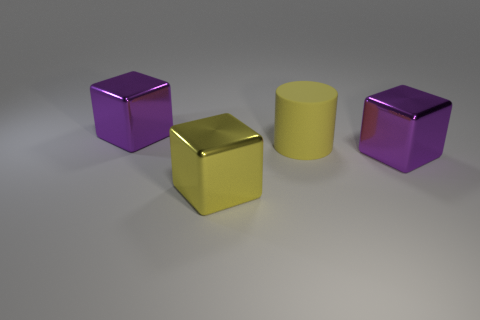How many other big things have the same color as the large rubber thing?
Your answer should be very brief. 1. Are there more tiny red rubber blocks than large cylinders?
Offer a very short reply. No. There is a metallic object that is both in front of the large matte thing and left of the rubber object; what is its size?
Make the answer very short. Large. Is the large purple thing that is behind the big yellow rubber cylinder made of the same material as the big purple object that is in front of the big yellow matte cylinder?
Ensure brevity in your answer.  Yes. What shape is the yellow object that is the same size as the yellow cylinder?
Give a very brief answer. Cube. Are there fewer purple cubes than large blue matte balls?
Provide a succinct answer. No. Is there a yellow object that is in front of the large purple cube in front of the matte thing?
Give a very brief answer. Yes. There is a metallic block that is behind the large purple thing in front of the cylinder; are there any big metallic things to the left of it?
Offer a very short reply. No. There is a thing right of the matte cylinder; does it have the same shape as the big purple metal object on the left side of the yellow shiny cube?
Provide a short and direct response. Yes. Are there fewer large rubber cylinders that are on the right side of the cylinder than green cylinders?
Your answer should be very brief. No. 